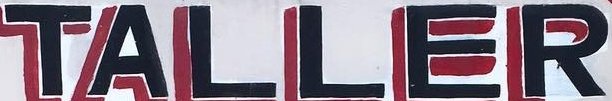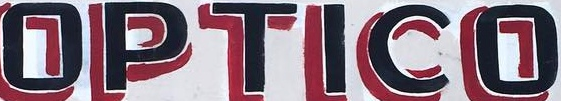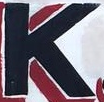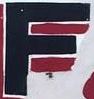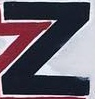Read the text content from these images in order, separated by a semicolon. TALLER; OPTICO; K; F; Z 